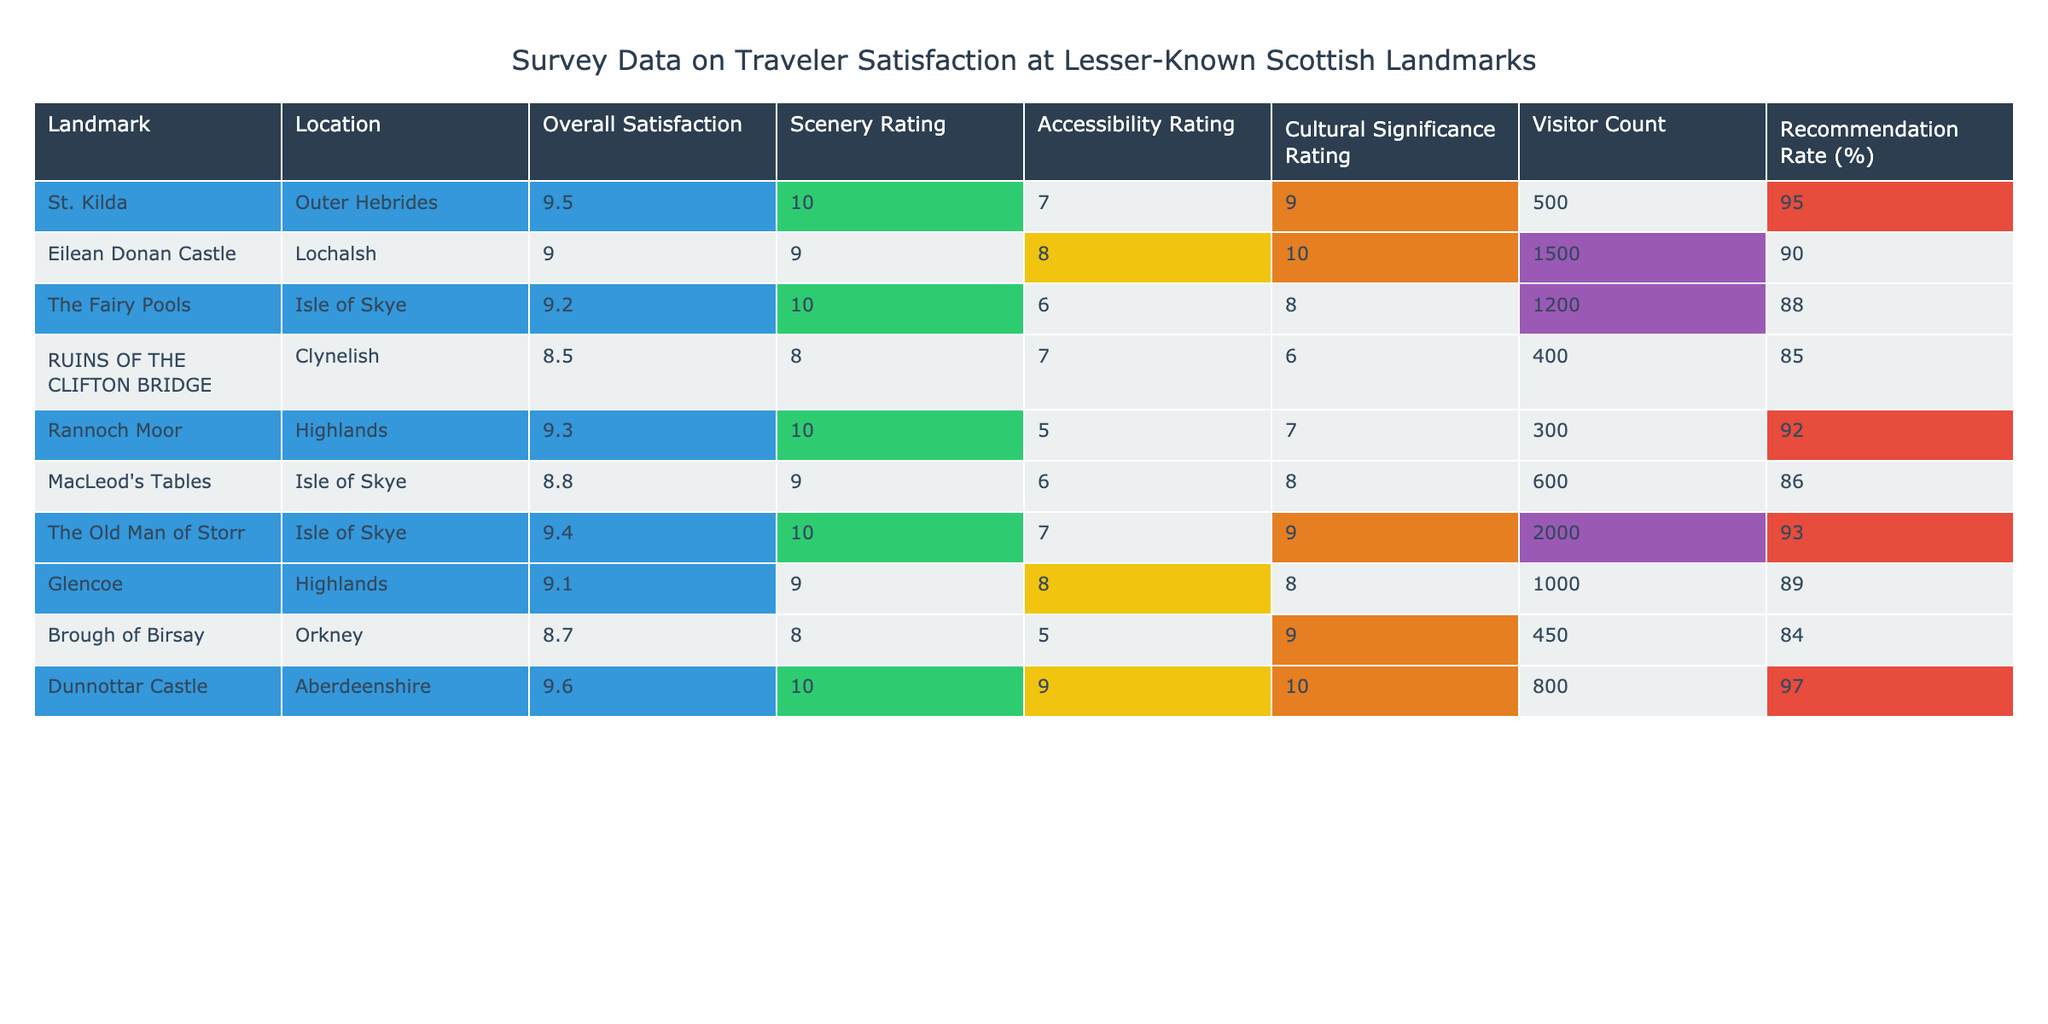What is the overall satisfaction rating for Dunnottar Castle? The table shows that the overall satisfaction rating for Dunnottar Castle is 9.6.
Answer: 9.6 Which landmark has the highest scenery rating? By looking at the scenery ratings, St. Kilda and The Old Man of Storr both have a rating of 10. Therefore, it's a tie between these two landmarks for the highest scenery rating.
Answer: St. Kilda and The Old Man of Storr What is the average accessibility rating for all landmarks listed? The accessibility ratings for the landmarks are 7, 8, 6, 7, 5, 6, 7, 8, 5, and 9. Adding these gives 63, and there are 10 landmarks. Thus, the average accessibility rating is 63/10 = 6.3.
Answer: 6.3 Is the recommendation rate for Eilean Donan Castle greater than 85%? Checking the table, the recommendation rate for Eilean Donan Castle is 90%, which is indeed greater than 85%.
Answer: Yes How many landmarks have an overall satisfaction rating greater than 9? The landmarks with an overall satisfaction greater than 9 are St. Kilda, Dunnottar Castle, The Old Man of Storr, and Rannoch Moor. Counting these gives a total of 4 landmarks.
Answer: 4 Which landmark has the lowest visitor count, and what is that count? Reviewing the visitor count across all landmarks, the Ruins of the Clifton Bridge has the lowest visitor count of 400.
Answer: Ruins of the Clifton Bridge, 400 What is the difference in overall satisfaction between the highest and lowest rated landmarks? The highest overall satisfaction is 9.6 (Dunnottar Castle) and the lowest is 8.5 (Ruins of the Clifton Bridge). The difference is 9.6 - 8.5 = 1.1.
Answer: 1.1 Is Glencoe's cultural significance rating higher than that of The Fairy Pools? According to the data, Glencoe has a cultural significance rating of 8, while The Fairy Pools have a rating of 8. Therefore, Glencoe does not have a higher cultural significance rating.
Answer: No 